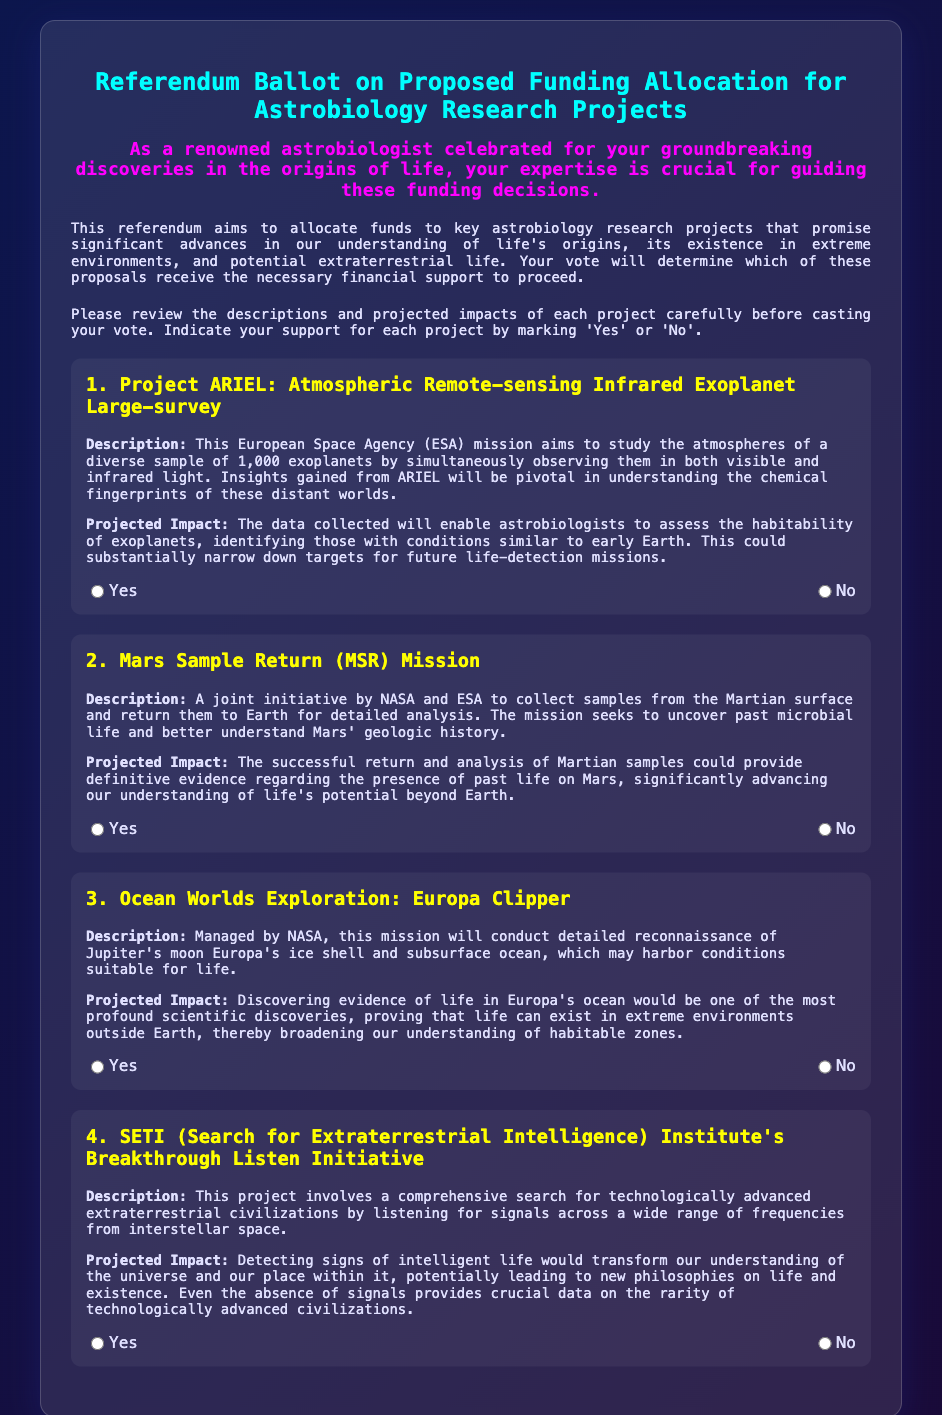What is the title of the ballot? The title is prominently displayed at the top of the document, referring to the purpose of the voting.
Answer: Referendum Ballot on Proposed Funding Allocation for Astrobiology Research Projects How many projects are described in the document? Counting the section headers for each project reveals the total number of distinct projects presented for voting.
Answer: 4 What is the main goal of Project ARIEL? The goal is specified in the project's description, focusing on its intent to study certain astronomical features.
Answer: Study the atmospheres of exoplanets What impact does the Mars Sample Return Mission seek to uncover? The projected impact section mentions the type of evidence the mission aims to discover regarding life.
Answer: Evidence regarding the presence of past life Which organization manages the Europa Clipper mission? The document provides information on the entity responsible for overseeing the mission detailed under the third project's description.
Answer: NASA What would detecting signs of intelligent life potentially transform? The projected impact of the SETI initiative highlights the significance of such a discovery on broader conceptual understandings.
Answer: Understanding of the universe Which project aims to analyze Martian samples? The project focuses on specific research activities related to the Martian surface and is explicitly named in the document.
Answer: Mars Sample Return Mission What type of signals is the Breakthrough Listen Initiative searching for? The description provides details on the nature of the signals being monitored by this project.
Answer: Technologically advanced extraterrestrial civilizations What is the projected outcome of discovering evidence of life in Europa's ocean? The impact section articulates the scientific implications of making such a discovery outside Earth.
Answer: Proving that life can exist in extreme environments 